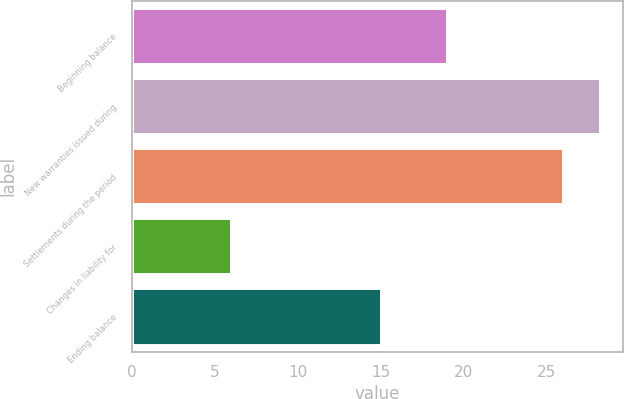Convert chart. <chart><loc_0><loc_0><loc_500><loc_500><bar_chart><fcel>Beginning balance<fcel>New warranties issued during<fcel>Settlements during the period<fcel>Changes in liability for<fcel>Ending balance<nl><fcel>19<fcel>28.2<fcel>26<fcel>6<fcel>15<nl></chart> 